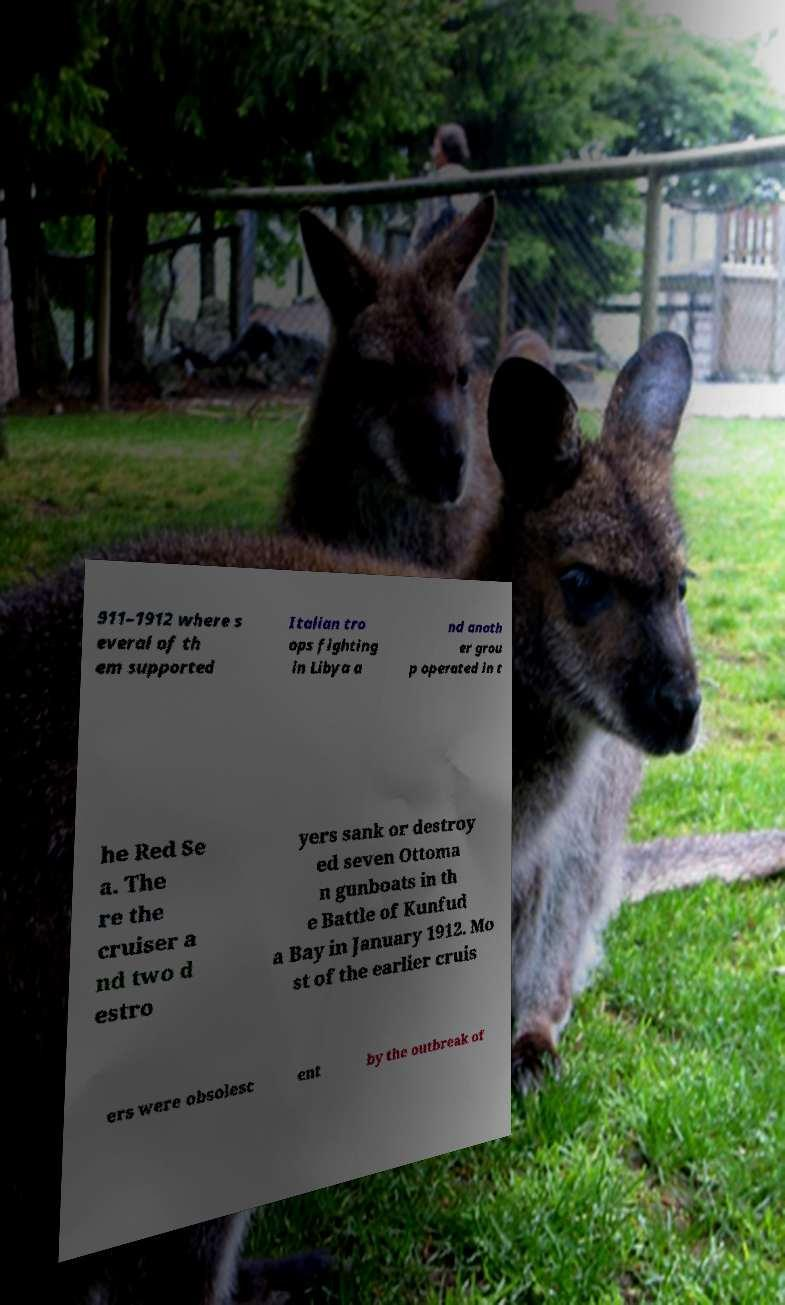Could you assist in decoding the text presented in this image and type it out clearly? 911–1912 where s everal of th em supported Italian tro ops fighting in Libya a nd anoth er grou p operated in t he Red Se a. The re the cruiser a nd two d estro yers sank or destroy ed seven Ottoma n gunboats in th e Battle of Kunfud a Bay in January 1912. Mo st of the earlier cruis ers were obsolesc ent by the outbreak of 